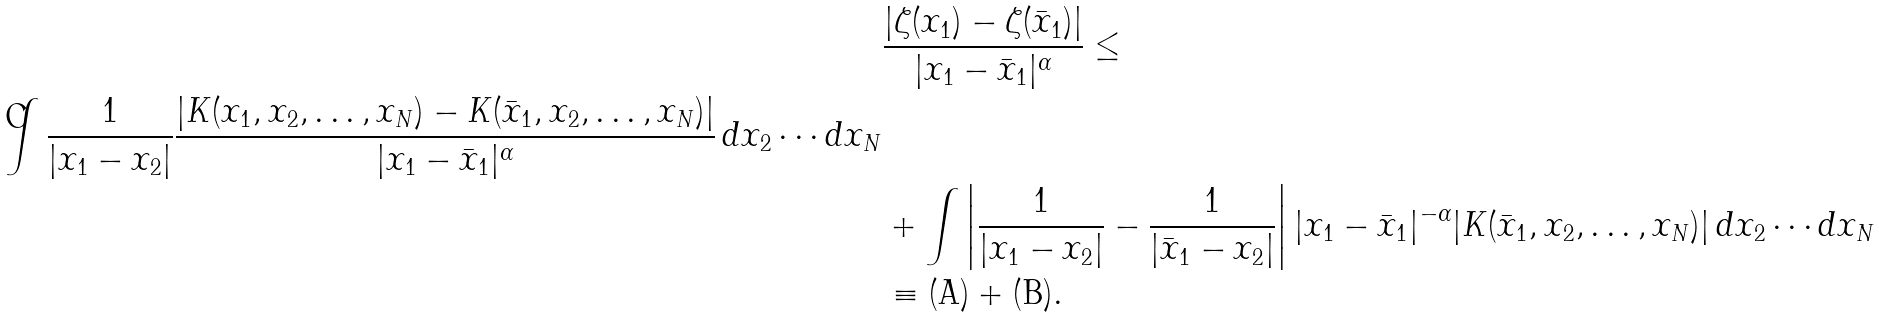Convert formula to latex. <formula><loc_0><loc_0><loc_500><loc_500>& \frac { | \zeta ( x _ { 1 } ) - \zeta ( \bar { x } _ { 1 } ) | } { | x _ { 1 } - \bar { x } _ { 1 } | ^ { \alpha } } \leq \\ \int \frac { 1 } { | x _ { 1 } - x _ { 2 } | } \frac { | K ( x _ { 1 } , x _ { 2 } , \dots , x _ { N } ) - K ( \bar { x } _ { 1 } , x _ { 2 } , \dots , x _ { N } ) | } { | x _ { 1 } - \bar { x } _ { 1 } | ^ { \alpha } } \, d x _ { 2 } \cdots d x _ { N } \\ & + \int \left | \frac { 1 } { | x _ { 1 } - x _ { 2 } | } - \frac { 1 } { | \bar { x } _ { 1 } - x _ { 2 } | } \right | | x _ { 1 } - \bar { x } _ { 1 } | ^ { - \alpha } | K ( \bar { x } _ { 1 } , x _ { 2 } , \dots , x _ { N } ) | \, d x _ { 2 } \cdots d x _ { N } \\ & \equiv ( \text {A} ) + ( \text {B} ) .</formula> 